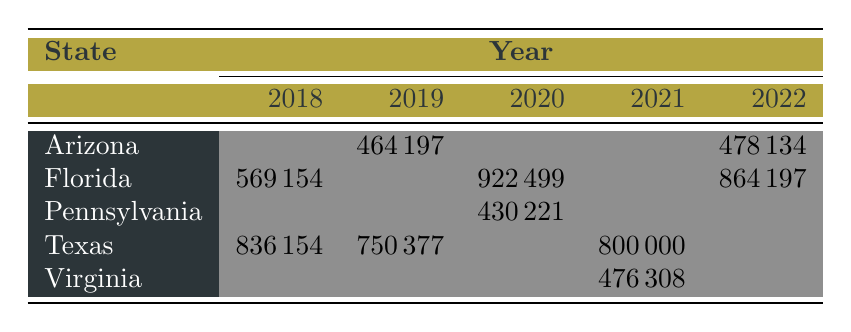What was the total sales of firearms in Texas for the year 2018? The table shows that in Texas for 2018, handgun sales were 523698 and rifle sales were 312456. Adding these together gives 523698 + 312456 = 836154.
Answer: 836154 Which state had the highest handgun sales in 2020? In the table, Florida shows handgun sales of 678932 in 2020, while no other state is listed with more than that. Therefore, Florida has the highest handgun sales.
Answer: Florida What is the average sales of rifles in Arizona over the years listed? Arizona's rifle sales listed are 176543 in 2019 and 0 in 2020, 0 in 2021, and 132456 in 2022, which gives us a total of 176543 + 0 + 0 + 132456 = 308999 for the two years that have data. Since there are 2 data points, the average is 308999/2 = 154499.5, rounding down gives us 154499.
Answer: 154499 Did Virginia have any significant sales in 2018? Looking at the table, Virginia has no data listed for 2018, indicating they had zero sales in that year.
Answer: No What was the increase in sales of handguns in Texas from 2018 to 2021? In Texas, handgun sales were 523698 in 2018 and 612345 in 2021. To find the increase, we subtract the 2018 sales from the 2021 sales: 612345 - 523698 = 88747.
Answer: 88747 What is the total sales for shotguns reported in Florida from 2018 to 2022? From the data, Florida's shotgun sales are listed as 156789 in 2018, 0 in 2019, 0 in 2020, 0 in 2021, and 0 in 2022. So only 156789 is considered, giving us a total of 156789 for the entire span.
Answer: 156789 Which gun type had the highest average price in 2021 across the states listed? From the table, the gun types and average prices in 2021 show handguns average at 625, AR-15 Style at 1250, and shotguns at 500. The AR-15 Style, averaging 1250, is the highest.
Answer: AR-15 Style Which state saw a decrease in handgun sales from 2019 to 2020? From the table, we see that Arizona had 287654 handgun sales in 2019 and dropped to 0 in 2020. Thus, there was a decrease.
Answer: Arizona 